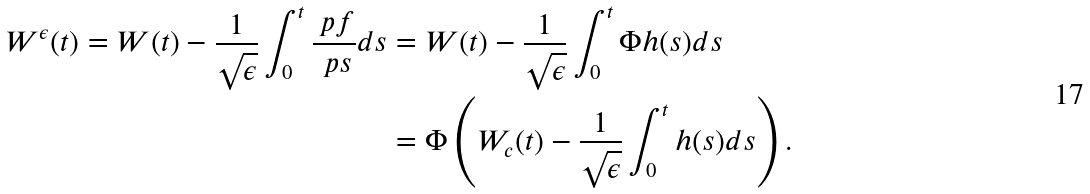<formula> <loc_0><loc_0><loc_500><loc_500>W ^ { \epsilon } ( t ) = W ( t ) - \frac { 1 } { \sqrt { \epsilon } } \int _ { 0 } ^ { t } \frac { \ p f } { \ p s } d s & = W ( t ) - \frac { 1 } { \sqrt { \epsilon } } \int _ { 0 } ^ { t } \Phi h ( s ) d s \\ & = \Phi \left ( W _ { c } ( t ) - \frac { 1 } { \sqrt { \epsilon } } \int _ { 0 } ^ { t } h ( s ) d s \right ) .</formula> 